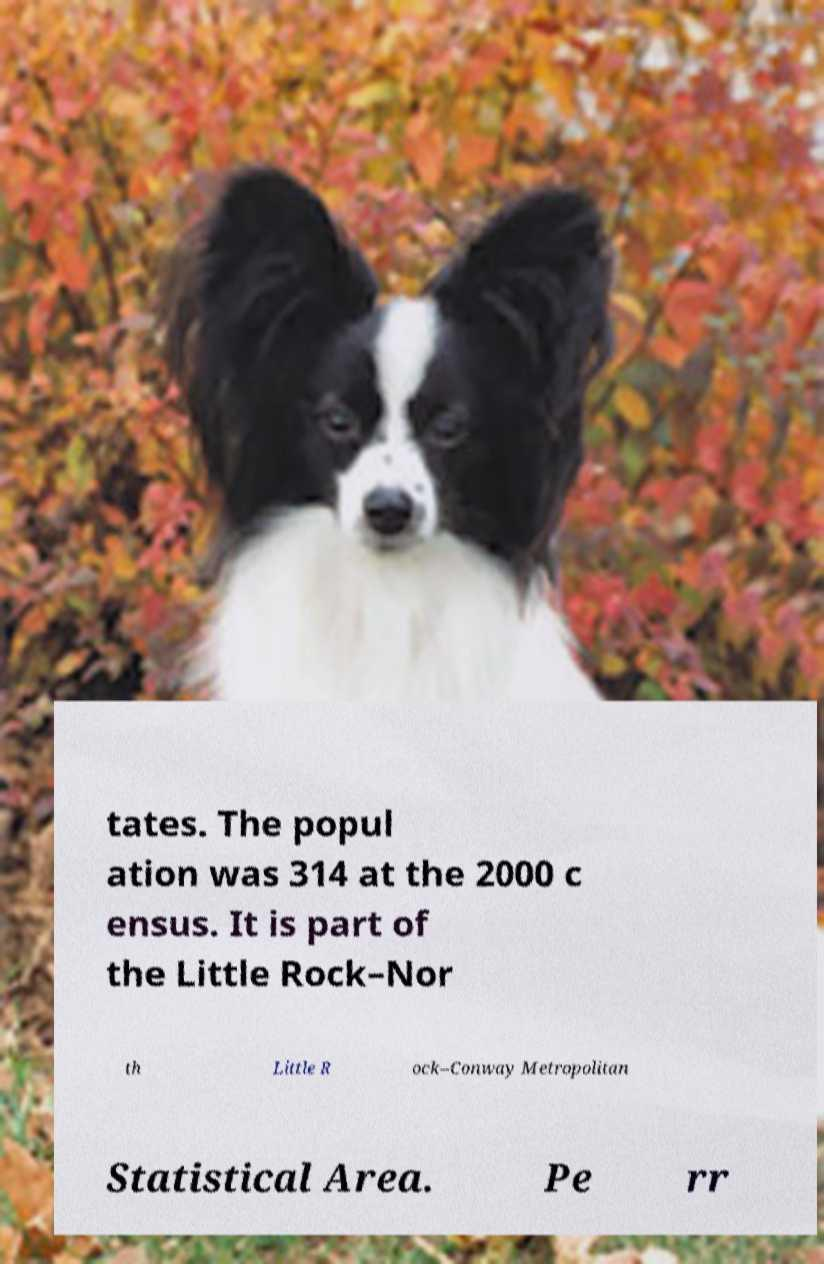Could you extract and type out the text from this image? tates. The popul ation was 314 at the 2000 c ensus. It is part of the Little Rock–Nor th Little R ock–Conway Metropolitan Statistical Area. Pe rr 